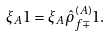Convert formula to latex. <formula><loc_0><loc_0><loc_500><loc_500>\xi _ { A } { 1 } = \xi _ { A } \hat { \rho } ^ { ( A ) } _ { f \mp } { 1 } .</formula> 